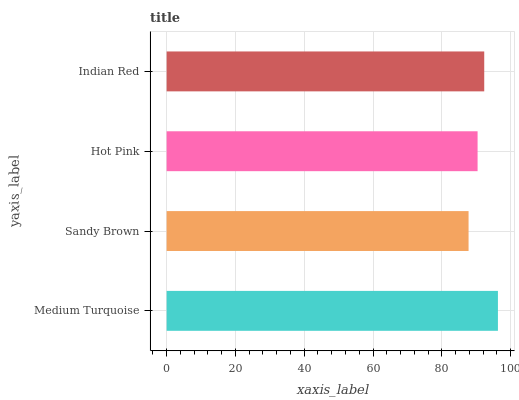Is Sandy Brown the minimum?
Answer yes or no. Yes. Is Medium Turquoise the maximum?
Answer yes or no. Yes. Is Hot Pink the minimum?
Answer yes or no. No. Is Hot Pink the maximum?
Answer yes or no. No. Is Hot Pink greater than Sandy Brown?
Answer yes or no. Yes. Is Sandy Brown less than Hot Pink?
Answer yes or no. Yes. Is Sandy Brown greater than Hot Pink?
Answer yes or no. No. Is Hot Pink less than Sandy Brown?
Answer yes or no. No. Is Indian Red the high median?
Answer yes or no. Yes. Is Hot Pink the low median?
Answer yes or no. Yes. Is Sandy Brown the high median?
Answer yes or no. No. Is Sandy Brown the low median?
Answer yes or no. No. 